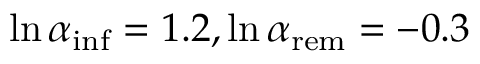<formula> <loc_0><loc_0><loc_500><loc_500>\ln { \alpha _ { i n f } } = 1 . 2 , \ln { \alpha _ { r e m } } = - 0 . 3</formula> 